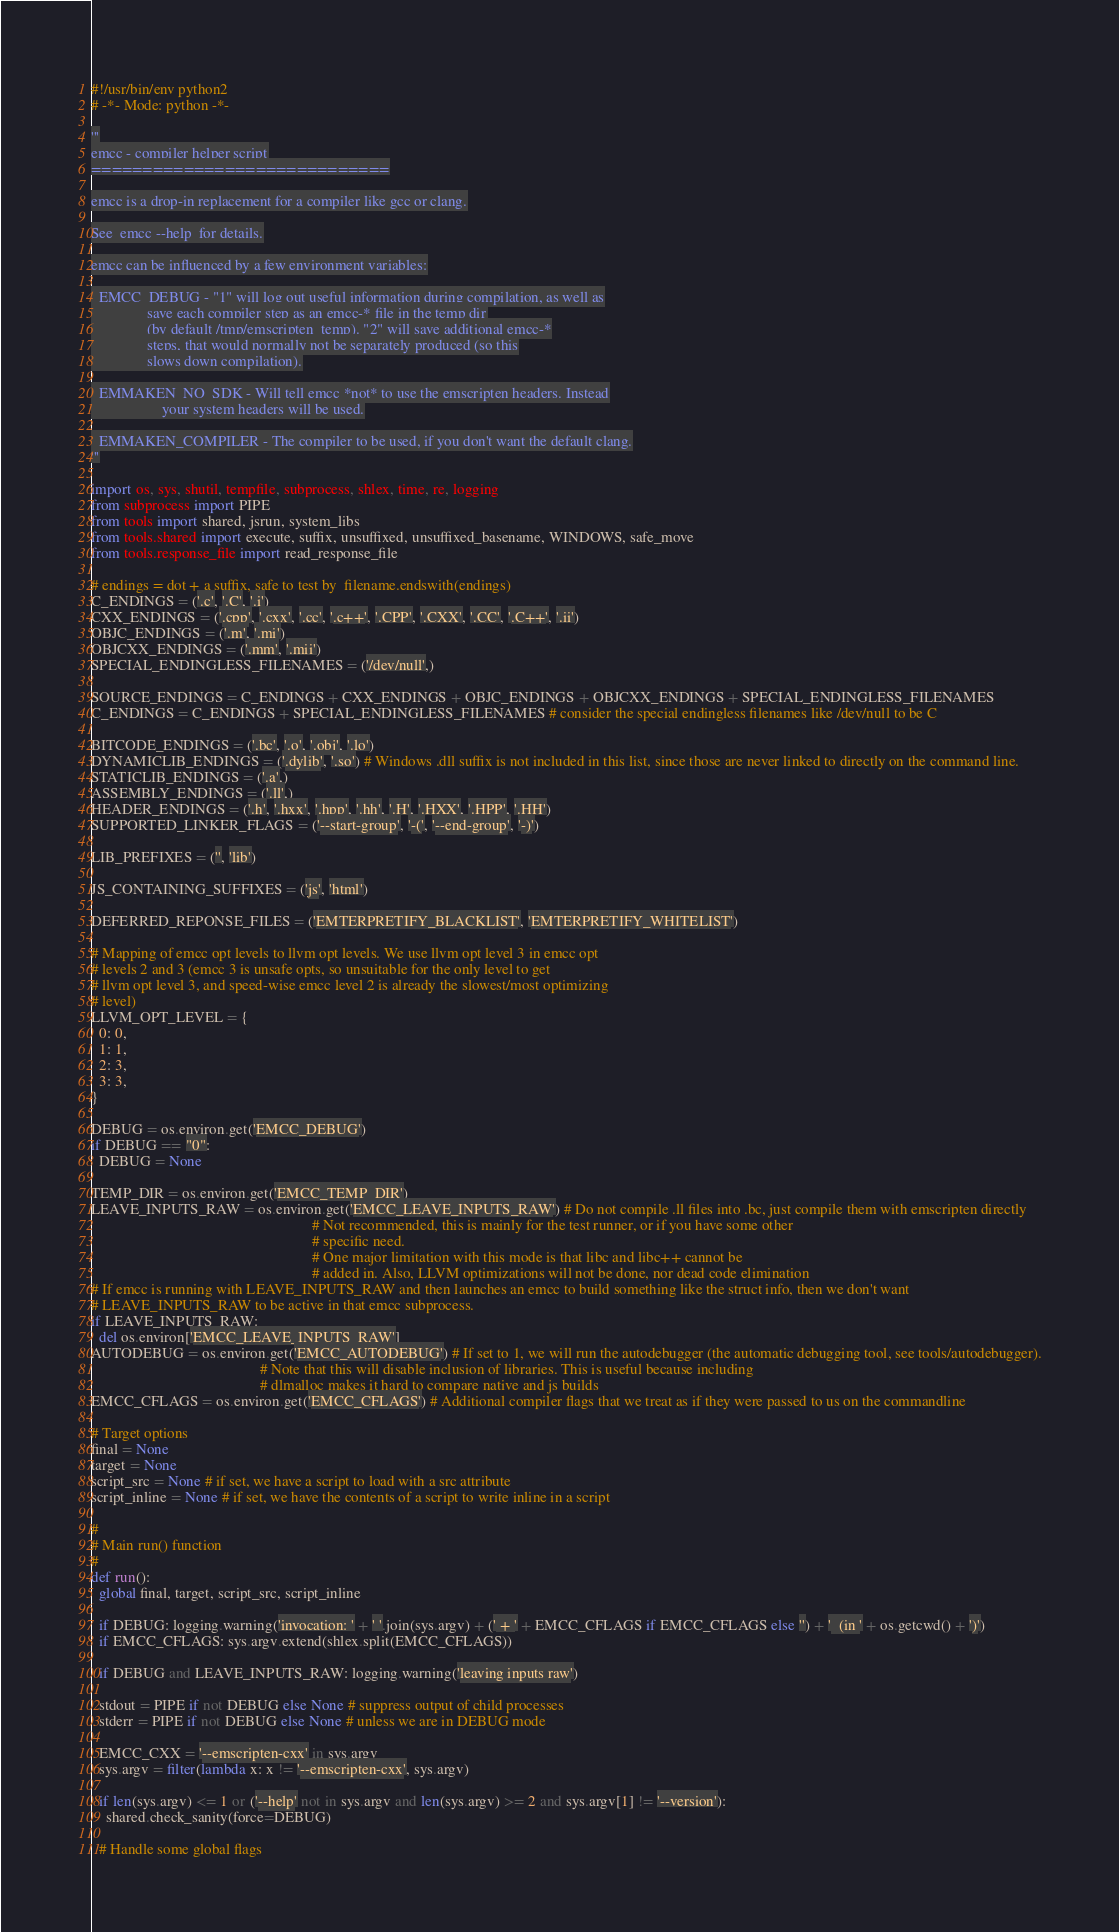Convert code to text. <code><loc_0><loc_0><loc_500><loc_500><_Python_>#!/usr/bin/env python2
# -*- Mode: python -*-

'''
emcc - compiler helper script
=============================

emcc is a drop-in replacement for a compiler like gcc or clang.

See  emcc --help  for details.

emcc can be influenced by a few environment variables:

  EMCC_DEBUG - "1" will log out useful information during compilation, as well as
               save each compiler step as an emcc-* file in the temp dir
               (by default /tmp/emscripten_temp). "2" will save additional emcc-*
               steps, that would normally not be separately produced (so this
               slows down compilation).

  EMMAKEN_NO_SDK - Will tell emcc *not* to use the emscripten headers. Instead
                   your system headers will be used.

  EMMAKEN_COMPILER - The compiler to be used, if you don't want the default clang.
'''

import os, sys, shutil, tempfile, subprocess, shlex, time, re, logging
from subprocess import PIPE
from tools import shared, jsrun, system_libs
from tools.shared import execute, suffix, unsuffixed, unsuffixed_basename, WINDOWS, safe_move
from tools.response_file import read_response_file

# endings = dot + a suffix, safe to test by  filename.endswith(endings)
C_ENDINGS = ('.c', '.C', '.i')
CXX_ENDINGS = ('.cpp', '.cxx', '.cc', '.c++', '.CPP', '.CXX', '.CC', '.C++', '.ii')
OBJC_ENDINGS = ('.m', '.mi')
OBJCXX_ENDINGS = ('.mm', '.mii')
SPECIAL_ENDINGLESS_FILENAMES = ('/dev/null',)

SOURCE_ENDINGS = C_ENDINGS + CXX_ENDINGS + OBJC_ENDINGS + OBJCXX_ENDINGS + SPECIAL_ENDINGLESS_FILENAMES
C_ENDINGS = C_ENDINGS + SPECIAL_ENDINGLESS_FILENAMES # consider the special endingless filenames like /dev/null to be C

BITCODE_ENDINGS = ('.bc', '.o', '.obj', '.lo')
DYNAMICLIB_ENDINGS = ('.dylib', '.so') # Windows .dll suffix is not included in this list, since those are never linked to directly on the command line.
STATICLIB_ENDINGS = ('.a',)
ASSEMBLY_ENDINGS = ('.ll',)
HEADER_ENDINGS = ('.h', '.hxx', '.hpp', '.hh', '.H', '.HXX', '.HPP', '.HH')
SUPPORTED_LINKER_FLAGS = ('--start-group', '-(', '--end-group', '-)')

LIB_PREFIXES = ('', 'lib')

JS_CONTAINING_SUFFIXES = ('js', 'html')

DEFERRED_REPONSE_FILES = ('EMTERPRETIFY_BLACKLIST', 'EMTERPRETIFY_WHITELIST')

# Mapping of emcc opt levels to llvm opt levels. We use llvm opt level 3 in emcc opt
# levels 2 and 3 (emcc 3 is unsafe opts, so unsuitable for the only level to get
# llvm opt level 3, and speed-wise emcc level 2 is already the slowest/most optimizing
# level)
LLVM_OPT_LEVEL = {
  0: 0,
  1: 1,
  2: 3,
  3: 3,
}

DEBUG = os.environ.get('EMCC_DEBUG')
if DEBUG == "0":
  DEBUG = None

TEMP_DIR = os.environ.get('EMCC_TEMP_DIR')
LEAVE_INPUTS_RAW = os.environ.get('EMCC_LEAVE_INPUTS_RAW') # Do not compile .ll files into .bc, just compile them with emscripten directly
                                                           # Not recommended, this is mainly for the test runner, or if you have some other
                                                           # specific need.
                                                           # One major limitation with this mode is that libc and libc++ cannot be
                                                           # added in. Also, LLVM optimizations will not be done, nor dead code elimination
# If emcc is running with LEAVE_INPUTS_RAW and then launches an emcc to build something like the struct info, then we don't want
# LEAVE_INPUTS_RAW to be active in that emcc subprocess.
if LEAVE_INPUTS_RAW:
  del os.environ['EMCC_LEAVE_INPUTS_RAW']
AUTODEBUG = os.environ.get('EMCC_AUTODEBUG') # If set to 1, we will run the autodebugger (the automatic debugging tool, see tools/autodebugger).
                                             # Note that this will disable inclusion of libraries. This is useful because including
                                             # dlmalloc makes it hard to compare native and js builds
EMCC_CFLAGS = os.environ.get('EMCC_CFLAGS') # Additional compiler flags that we treat as if they were passed to us on the commandline

# Target options
final = None
target = None
script_src = None # if set, we have a script to load with a src attribute
script_inline = None # if set, we have the contents of a script to write inline in a script

#
# Main run() function
#
def run():
  global final, target, script_src, script_inline

  if DEBUG: logging.warning('invocation: ' + ' '.join(sys.argv) + (' + ' + EMCC_CFLAGS if EMCC_CFLAGS else '') + '  (in ' + os.getcwd() + ')')
  if EMCC_CFLAGS: sys.argv.extend(shlex.split(EMCC_CFLAGS))

  if DEBUG and LEAVE_INPUTS_RAW: logging.warning('leaving inputs raw')

  stdout = PIPE if not DEBUG else None # suppress output of child processes
  stderr = PIPE if not DEBUG else None # unless we are in DEBUG mode

  EMCC_CXX = '--emscripten-cxx' in sys.argv
  sys.argv = filter(lambda x: x != '--emscripten-cxx', sys.argv)

  if len(sys.argv) <= 1 or ('--help' not in sys.argv and len(sys.argv) >= 2 and sys.argv[1] != '--version'):
    shared.check_sanity(force=DEBUG)

  # Handle some global flags
</code> 